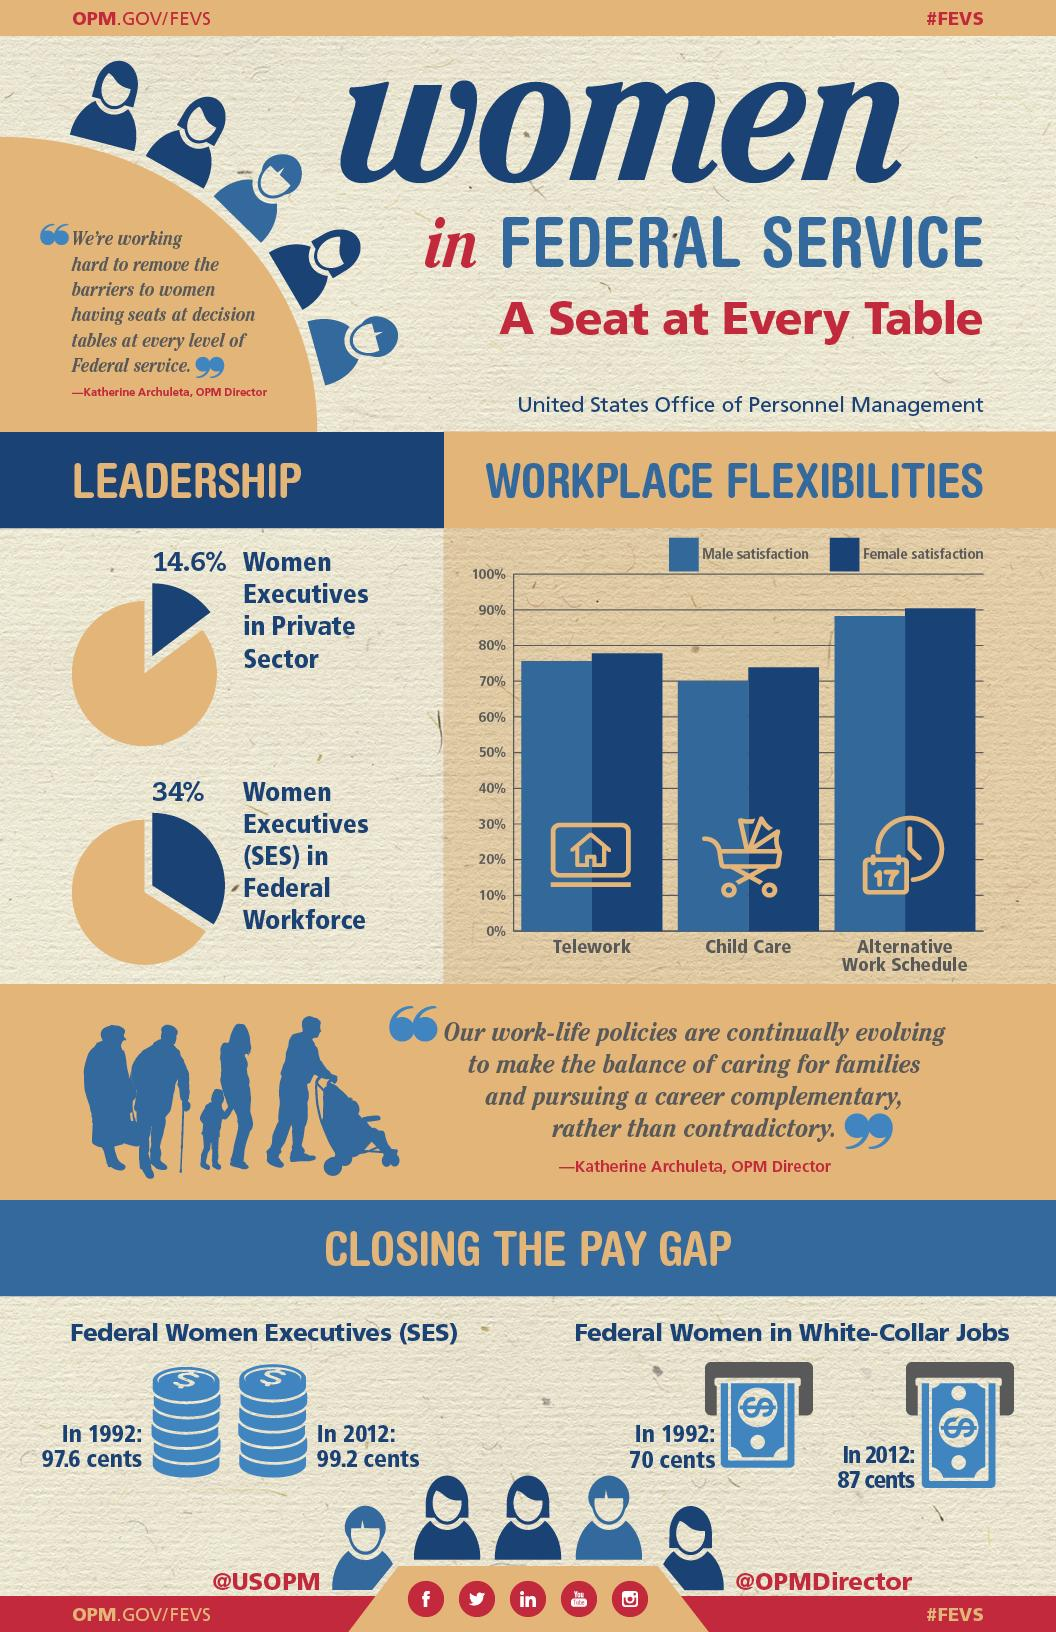Highlight a few significant elements in this photo. Approximately 14.6% of all executive positions in the private sector of the United States are held by women. In 2012, the average salary of female white-collar workers in federal jobs in the United States was 87 cents for every dollar earned by their male counterparts. In 1992, the salary of female executives in the federal government of the United States was equal to 97.6 cents for every dollar earned by their male counterparts, a significant improvement from the previous year. Of all SES positions in the federal workforce of the United States, 34% are currently occupied by women. The female satisfaction rate in the United States for an alternative work schedule is 90%. 